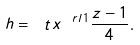<formula> <loc_0><loc_0><loc_500><loc_500>h = \ t x ^ { \ r l 1 } \frac { z - 1 } 4 .</formula> 